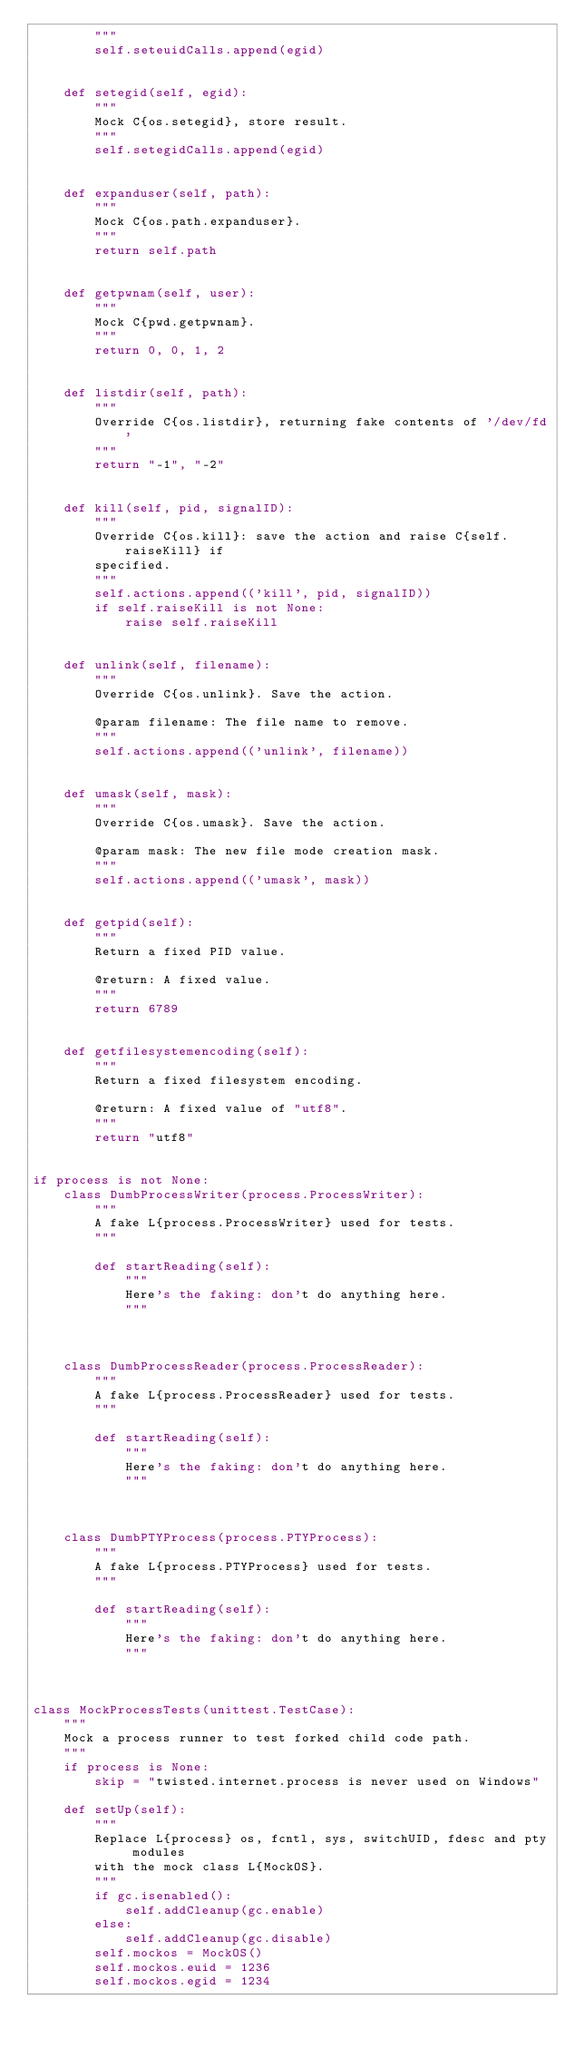<code> <loc_0><loc_0><loc_500><loc_500><_Python_>        """
        self.seteuidCalls.append(egid)


    def setegid(self, egid):
        """
        Mock C{os.setegid}, store result.
        """
        self.setegidCalls.append(egid)


    def expanduser(self, path):
        """
        Mock C{os.path.expanduser}.
        """
        return self.path


    def getpwnam(self, user):
        """
        Mock C{pwd.getpwnam}.
        """
        return 0, 0, 1, 2


    def listdir(self, path):
        """
        Override C{os.listdir}, returning fake contents of '/dev/fd'
        """
        return "-1", "-2"


    def kill(self, pid, signalID):
        """
        Override C{os.kill}: save the action and raise C{self.raiseKill} if
        specified.
        """
        self.actions.append(('kill', pid, signalID))
        if self.raiseKill is not None:
            raise self.raiseKill


    def unlink(self, filename):
        """
        Override C{os.unlink}. Save the action.

        @param filename: The file name to remove.
        """
        self.actions.append(('unlink', filename))


    def umask(self, mask):
        """
        Override C{os.umask}. Save the action.

        @param mask: The new file mode creation mask.
        """
        self.actions.append(('umask', mask))


    def getpid(self):
        """
        Return a fixed PID value.

        @return: A fixed value.
        """
        return 6789


    def getfilesystemencoding(self):
        """
        Return a fixed filesystem encoding.

        @return: A fixed value of "utf8".
        """
        return "utf8"


if process is not None:
    class DumbProcessWriter(process.ProcessWriter):
        """
        A fake L{process.ProcessWriter} used for tests.
        """

        def startReading(self):
            """
            Here's the faking: don't do anything here.
            """



    class DumbProcessReader(process.ProcessReader):
        """
        A fake L{process.ProcessReader} used for tests.
        """

        def startReading(self):
            """
            Here's the faking: don't do anything here.
            """



    class DumbPTYProcess(process.PTYProcess):
        """
        A fake L{process.PTYProcess} used for tests.
        """

        def startReading(self):
            """
            Here's the faking: don't do anything here.
            """



class MockProcessTests(unittest.TestCase):
    """
    Mock a process runner to test forked child code path.
    """
    if process is None:
        skip = "twisted.internet.process is never used on Windows"

    def setUp(self):
        """
        Replace L{process} os, fcntl, sys, switchUID, fdesc and pty modules
        with the mock class L{MockOS}.
        """
        if gc.isenabled():
            self.addCleanup(gc.enable)
        else:
            self.addCleanup(gc.disable)
        self.mockos = MockOS()
        self.mockos.euid = 1236
        self.mockos.egid = 1234</code> 